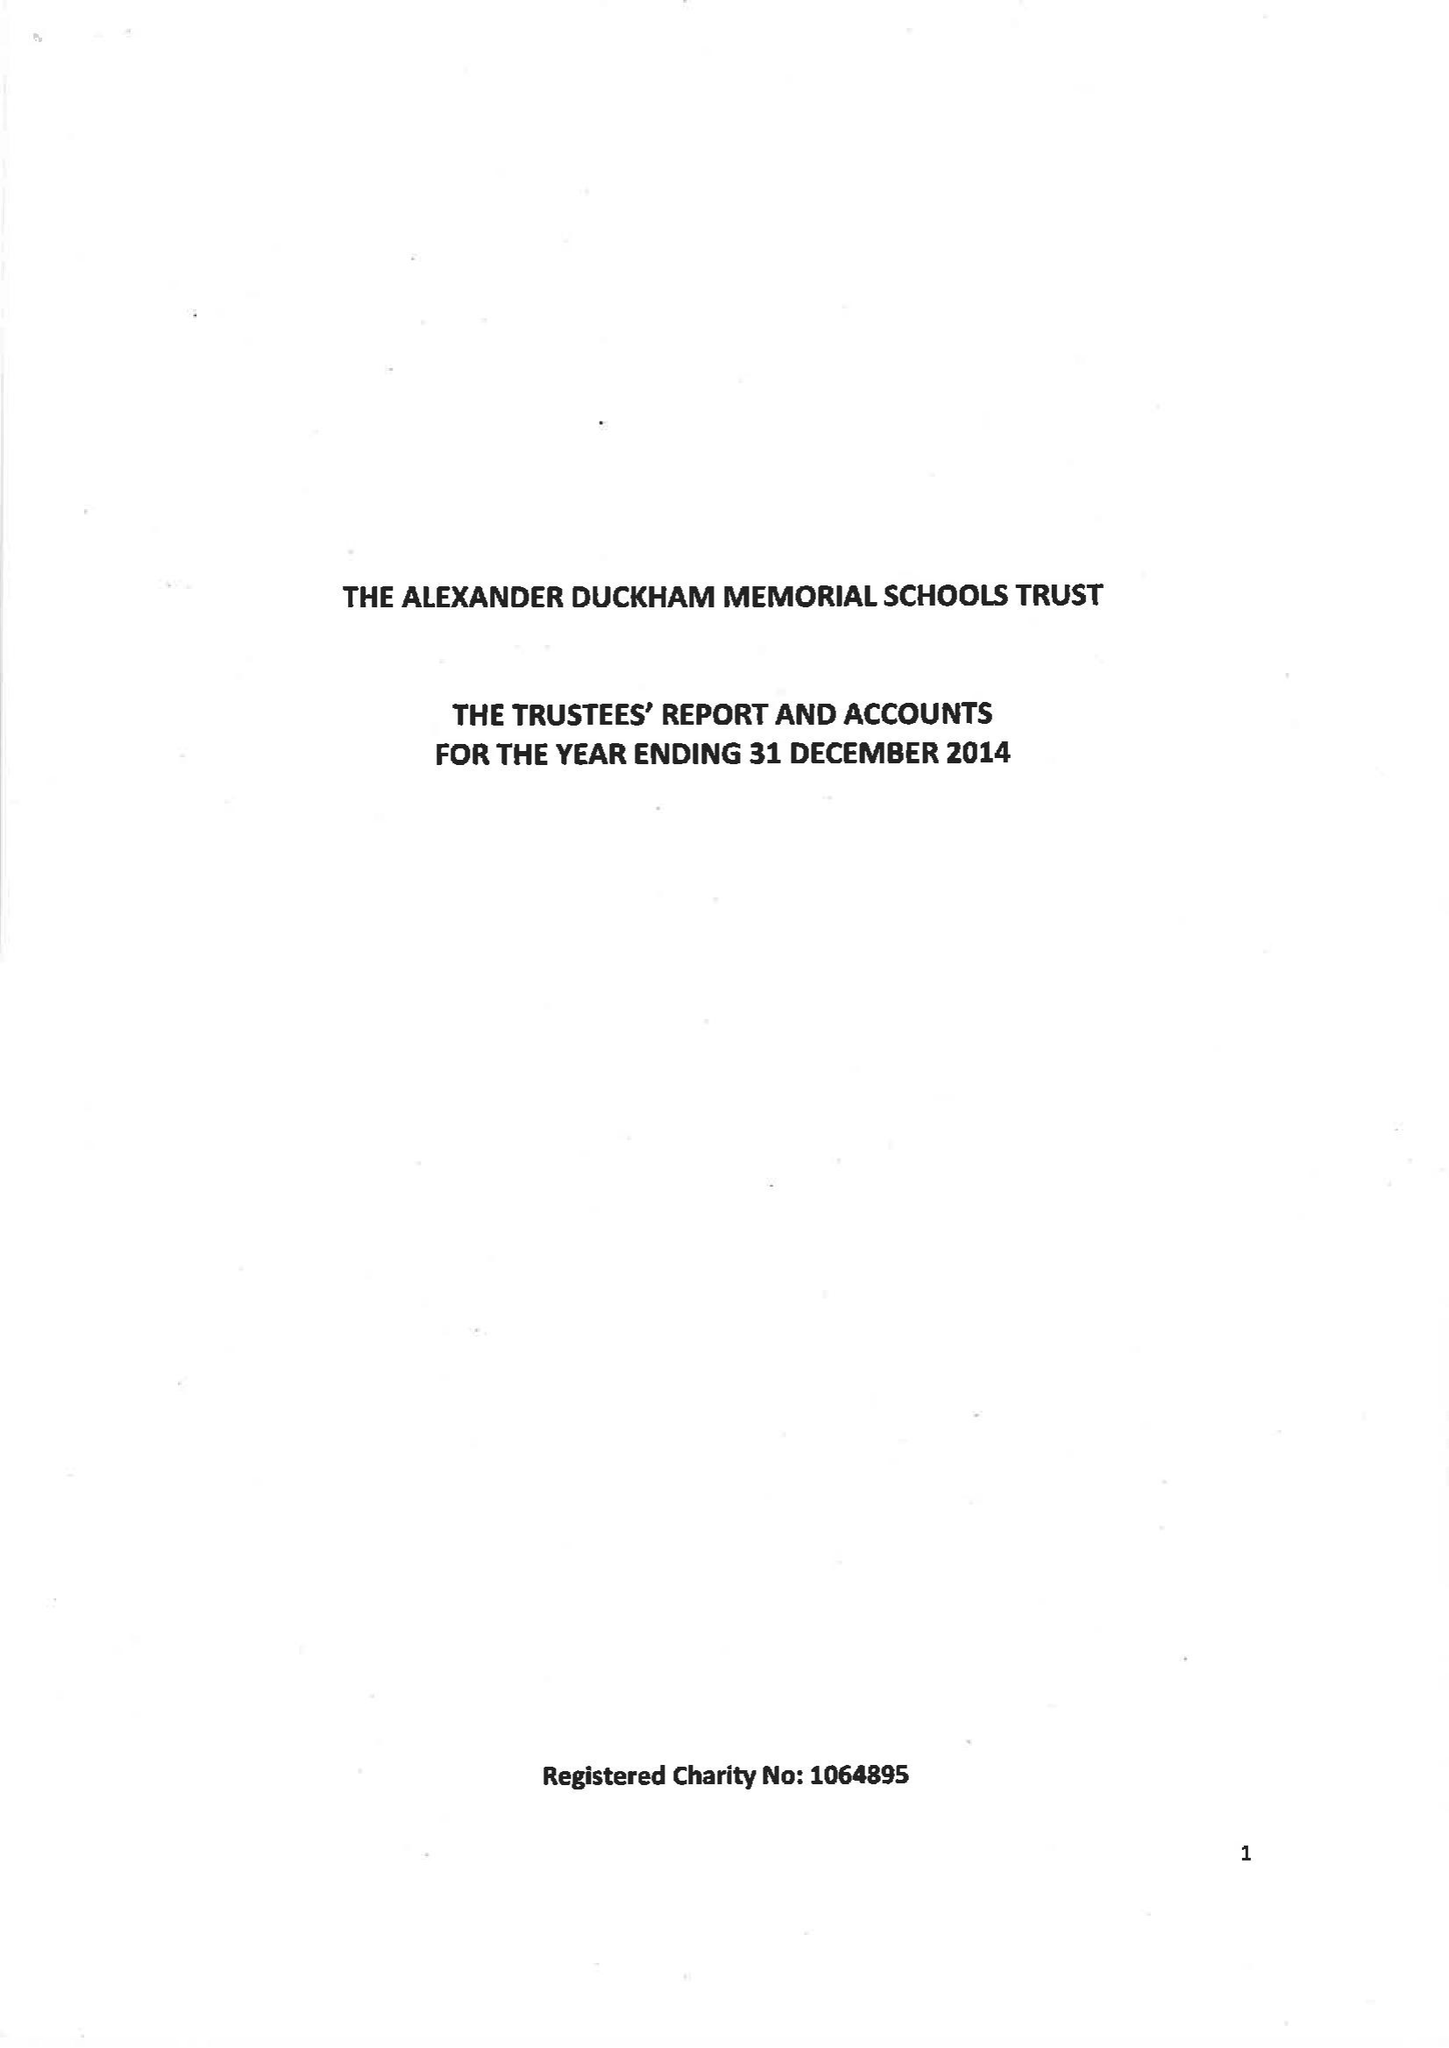What is the value for the income_annually_in_british_pounds?
Answer the question using a single word or phrase. 116000.00 